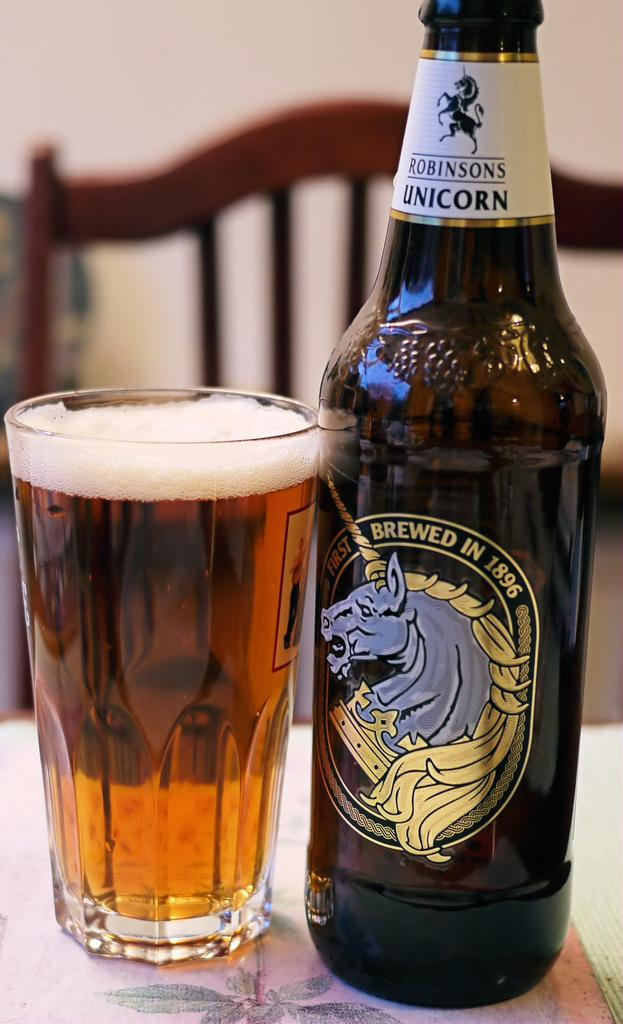<image>
Share a concise interpretation of the image provided. A bottle of Robinsons Unicorn proclaims it was first brewed in 1896. 